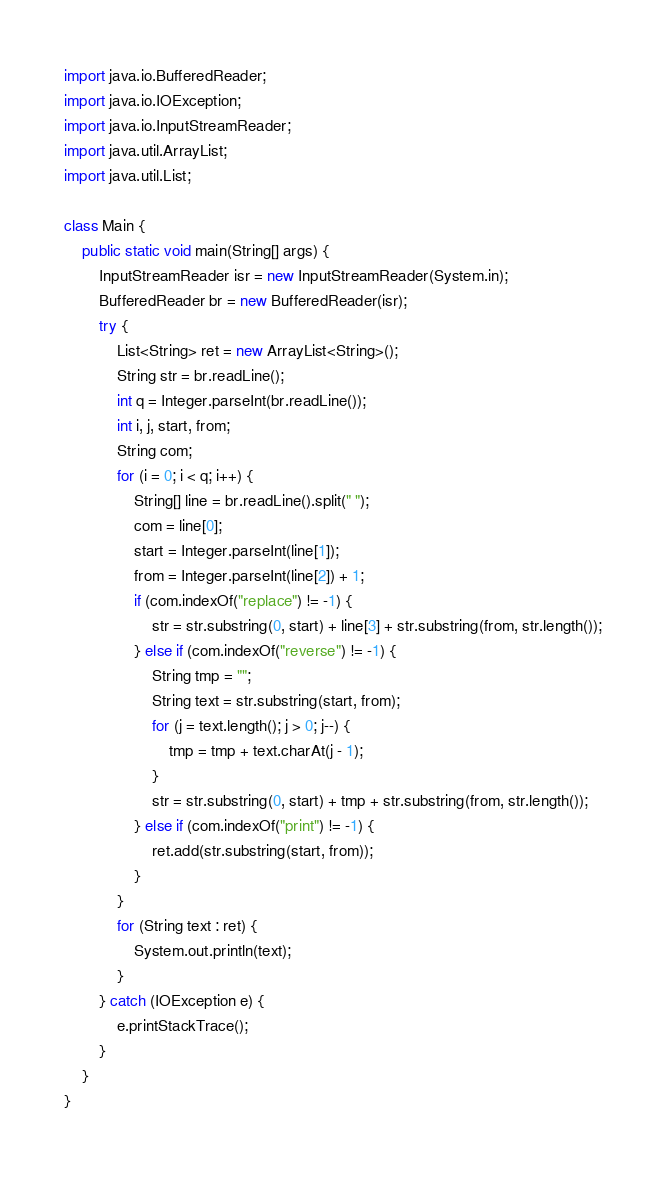<code> <loc_0><loc_0><loc_500><loc_500><_Java_>import java.io.BufferedReader;
import java.io.IOException;
import java.io.InputStreamReader;
import java.util.ArrayList;
import java.util.List;

class Main {
	public static void main(String[] args) {
		InputStreamReader isr = new InputStreamReader(System.in);
		BufferedReader br = new BufferedReader(isr);
		try {
			List<String> ret = new ArrayList<String>();
			String str = br.readLine();
			int q = Integer.parseInt(br.readLine());
			int i, j, start, from;
			String com;
			for (i = 0; i < q; i++) {
				String[] line = br.readLine().split(" ");
				com = line[0];
				start = Integer.parseInt(line[1]);
				from = Integer.parseInt(line[2]) + 1;
				if (com.indexOf("replace") != -1) {
					str = str.substring(0, start) + line[3] + str.substring(from, str.length());
				} else if (com.indexOf("reverse") != -1) {
					String tmp = "";
					String text = str.substring(start, from);
					for (j = text.length(); j > 0; j--) {
						tmp = tmp + text.charAt(j - 1);
					}
					str = str.substring(0, start) + tmp + str.substring(from, str.length());
				} else if (com.indexOf("print") != -1) {
					ret.add(str.substring(start, from));
				}
			}
			for (String text : ret) {
				System.out.println(text);
			}
		} catch (IOException e) {
			e.printStackTrace();
		}
	}
}</code> 